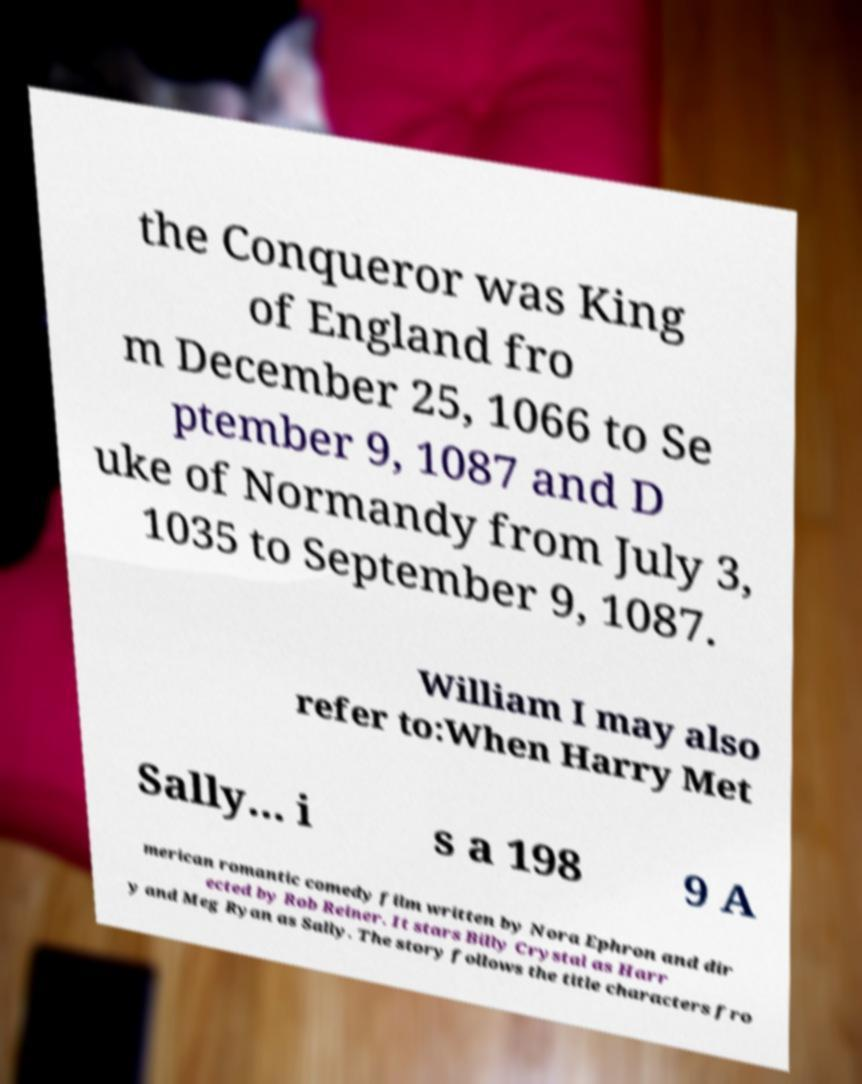What messages or text are displayed in this image? I need them in a readable, typed format. the Conqueror was King of England fro m December 25, 1066 to Se ptember 9, 1087 and D uke of Normandy from July 3, 1035 to September 9, 1087. William I may also refer to:When Harry Met Sally... i s a 198 9 A merican romantic comedy film written by Nora Ephron and dir ected by Rob Reiner. It stars Billy Crystal as Harr y and Meg Ryan as Sally. The story follows the title characters fro 